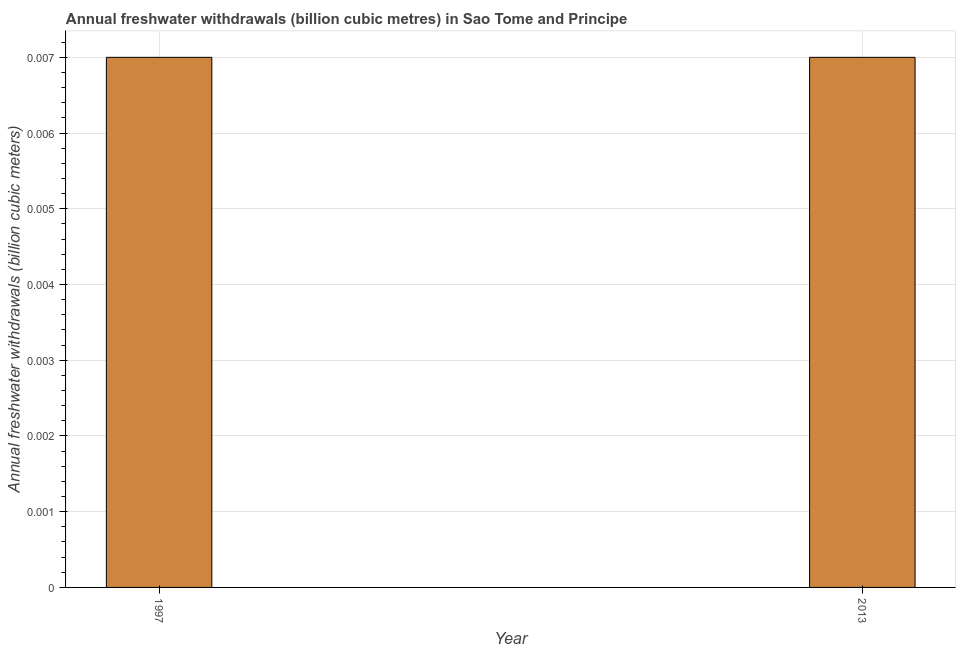Does the graph contain grids?
Make the answer very short. Yes. What is the title of the graph?
Offer a very short reply. Annual freshwater withdrawals (billion cubic metres) in Sao Tome and Principe. What is the label or title of the X-axis?
Keep it short and to the point. Year. What is the label or title of the Y-axis?
Provide a succinct answer. Annual freshwater withdrawals (billion cubic meters). What is the annual freshwater withdrawals in 1997?
Make the answer very short. 0.01. Across all years, what is the maximum annual freshwater withdrawals?
Your answer should be very brief. 0.01. Across all years, what is the minimum annual freshwater withdrawals?
Give a very brief answer. 0.01. What is the sum of the annual freshwater withdrawals?
Provide a short and direct response. 0.01. What is the average annual freshwater withdrawals per year?
Provide a short and direct response. 0.01. What is the median annual freshwater withdrawals?
Give a very brief answer. 0.01. Do a majority of the years between 2013 and 1997 (inclusive) have annual freshwater withdrawals greater than 0.0056 billion cubic meters?
Your answer should be compact. No. Is the annual freshwater withdrawals in 1997 less than that in 2013?
Ensure brevity in your answer.  No. In how many years, is the annual freshwater withdrawals greater than the average annual freshwater withdrawals taken over all years?
Your answer should be very brief. 0. What is the difference between two consecutive major ticks on the Y-axis?
Your response must be concise. 0. Are the values on the major ticks of Y-axis written in scientific E-notation?
Offer a terse response. No. What is the Annual freshwater withdrawals (billion cubic meters) of 1997?
Make the answer very short. 0.01. What is the Annual freshwater withdrawals (billion cubic meters) in 2013?
Provide a short and direct response. 0.01. What is the difference between the Annual freshwater withdrawals (billion cubic meters) in 1997 and 2013?
Ensure brevity in your answer.  0. What is the ratio of the Annual freshwater withdrawals (billion cubic meters) in 1997 to that in 2013?
Ensure brevity in your answer.  1. 